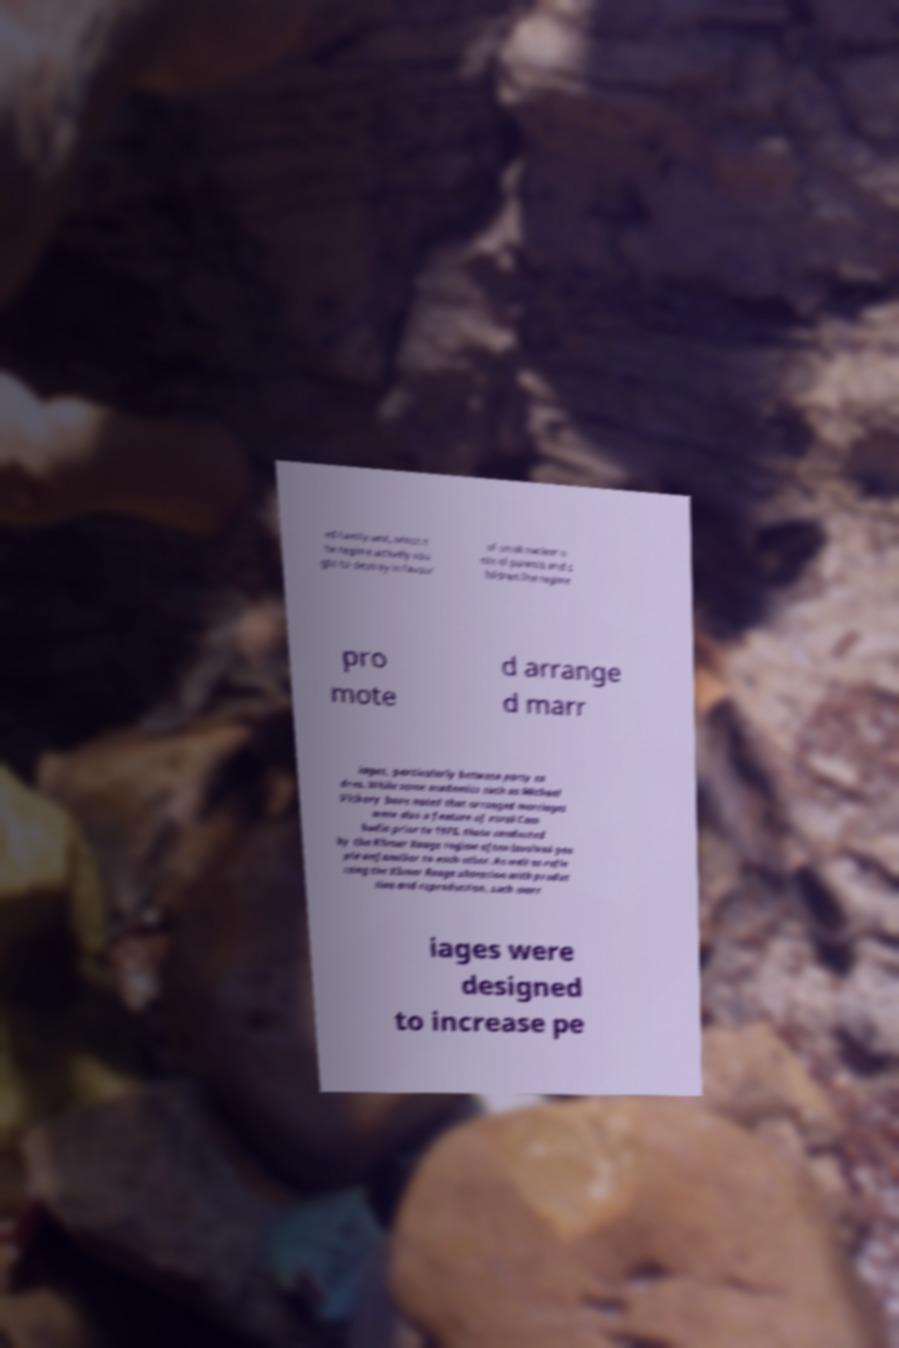I need the written content from this picture converted into text. Can you do that? ed family unit, which t he regime actively sou ght to destroy in favour of small nuclear u nits of parents and c hildren.The regime pro mote d arrange d marr iages, particularly between party ca dres. While some academics such as Michael Vickery have noted that arranged marriages were also a feature of rural Cam bodia prior to 1975, those conducted by the Khmer Rouge regime often involved peo ple unfamiliar to each other. As well as refle cting the Khmer Rouge obsession with produc tion and reproduction, such marr iages were designed to increase pe 